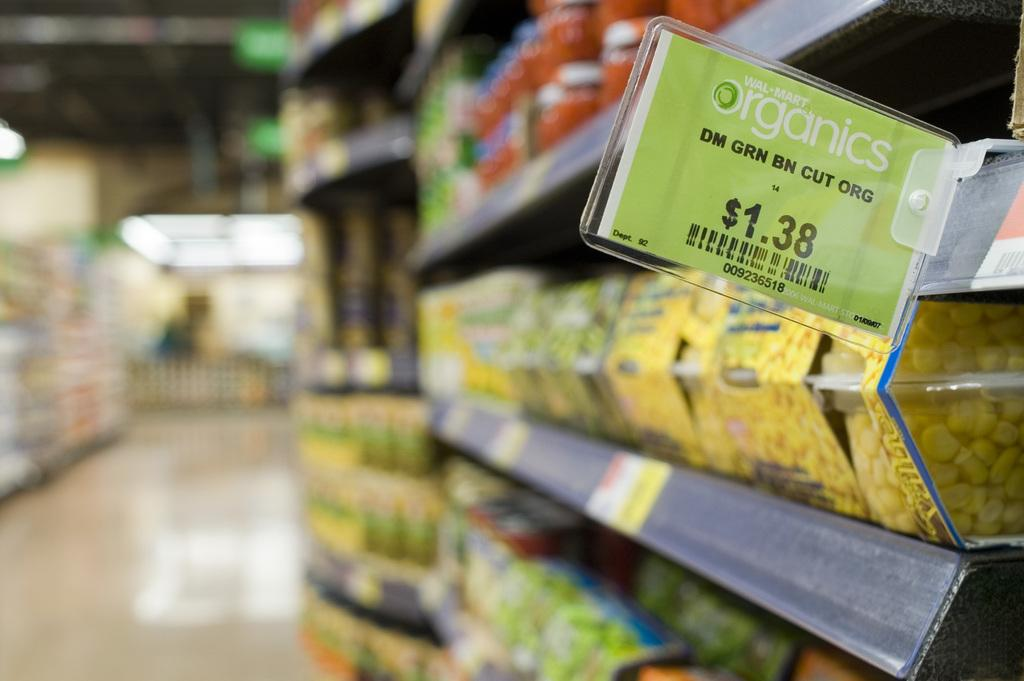<image>
Describe the image concisely. A Wal-Mart organics sign sticks out from a store shelf. 